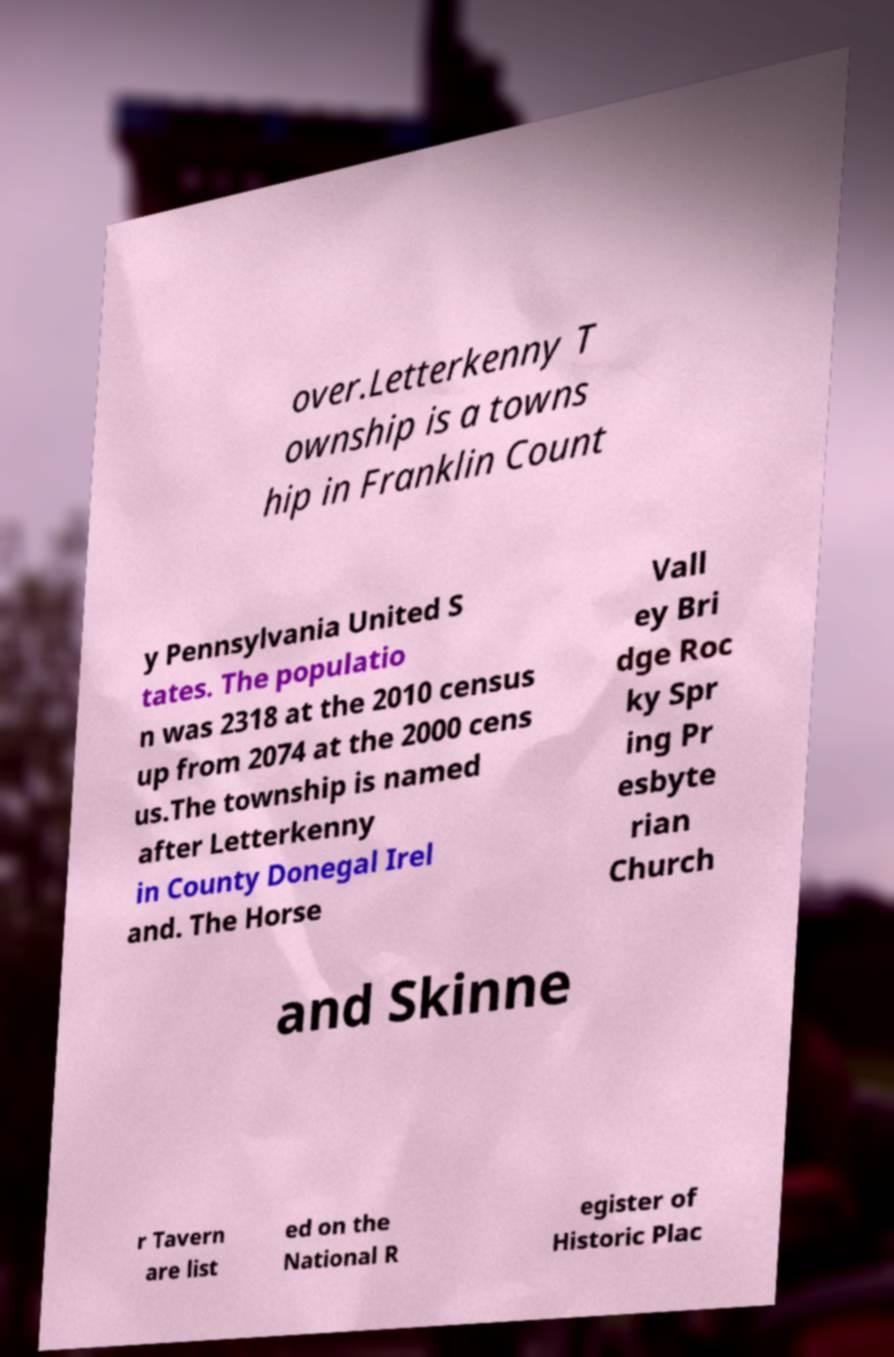There's text embedded in this image that I need extracted. Can you transcribe it verbatim? over.Letterkenny T ownship is a towns hip in Franklin Count y Pennsylvania United S tates. The populatio n was 2318 at the 2010 census up from 2074 at the 2000 cens us.The township is named after Letterkenny in County Donegal Irel and. The Horse Vall ey Bri dge Roc ky Spr ing Pr esbyte rian Church and Skinne r Tavern are list ed on the National R egister of Historic Plac 